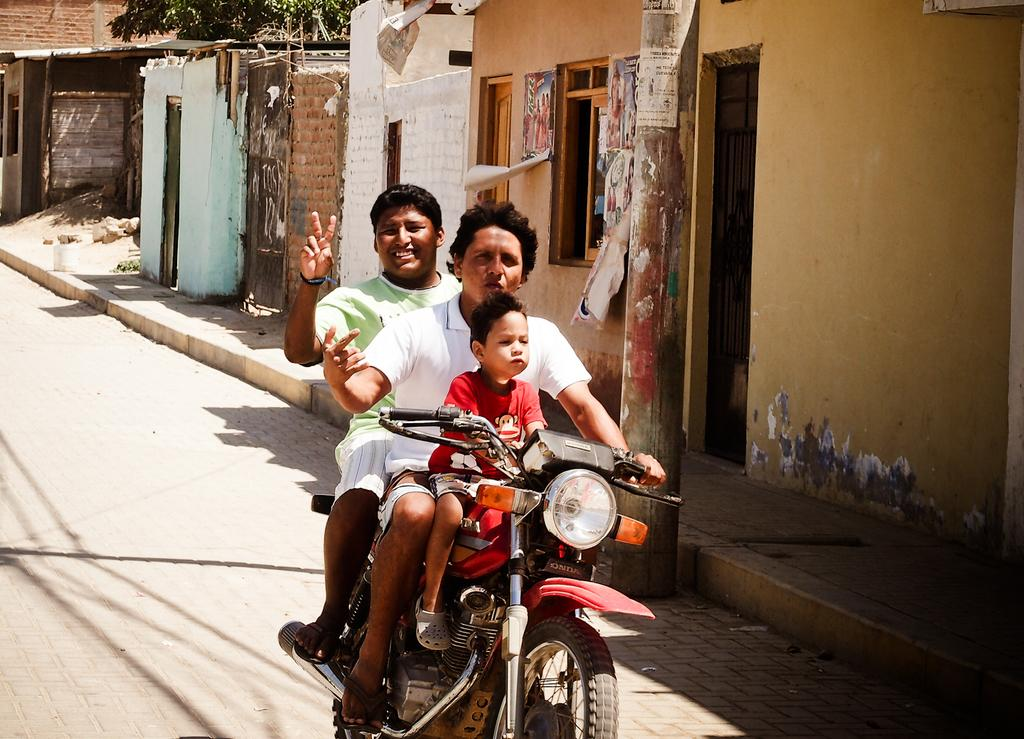How many people are on the bike in the image? There are three persons sitting on a bike in the image. What can be seen in the background of the image? In the background, there is a building, a tree, a door, a road, and stones. Can you describe the setting of the image? The image shows a bike with three people on it, and the background features a mix of natural and man-made elements. What type of business is being conducted in the image? There is no indication of any business being conducted in the image; it primarily features a bike with three people on it and a background setting. 